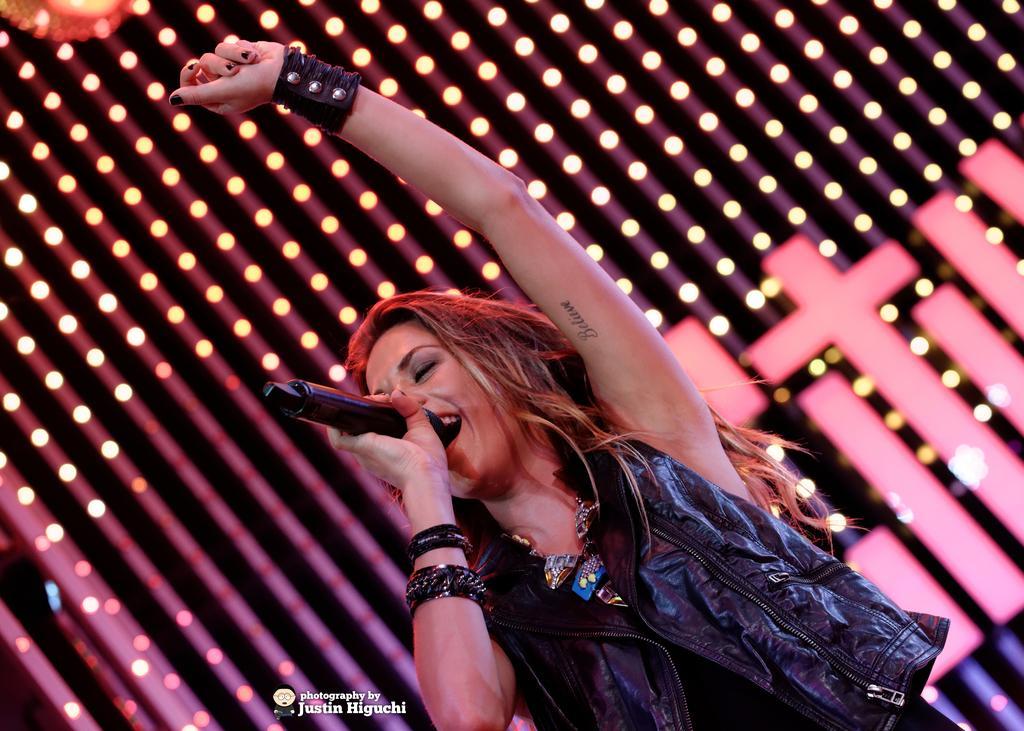Please provide a concise description of this image. This is a woman standing and singing a song. She is holding a mike. She wore a black leather jacket, necklace, bangles and hand band. In the background, I can see the lights. This is the watermark on the image. 